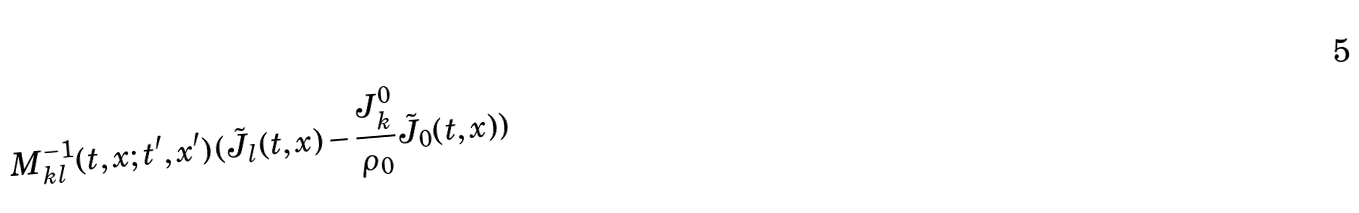<formula> <loc_0><loc_0><loc_500><loc_500>M ^ { - 1 } _ { k l } ( t , x ; t ^ { \prime } , x ^ { \prime } ) \, ( { \tilde { J } } _ { l } ( t , x ) - \frac { J ^ { 0 } _ { k } } { \rho _ { 0 } } { \tilde { J } } _ { 0 } ( t , x ) )</formula> 